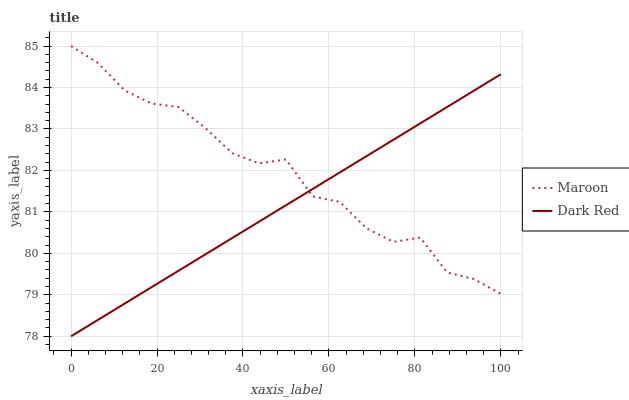Does Dark Red have the minimum area under the curve?
Answer yes or no. Yes. Does Maroon have the maximum area under the curve?
Answer yes or no. Yes. Does Maroon have the minimum area under the curve?
Answer yes or no. No. Is Dark Red the smoothest?
Answer yes or no. Yes. Is Maroon the roughest?
Answer yes or no. Yes. Is Maroon the smoothest?
Answer yes or no. No. Does Dark Red have the lowest value?
Answer yes or no. Yes. Does Maroon have the lowest value?
Answer yes or no. No. Does Maroon have the highest value?
Answer yes or no. Yes. Does Maroon intersect Dark Red?
Answer yes or no. Yes. Is Maroon less than Dark Red?
Answer yes or no. No. Is Maroon greater than Dark Red?
Answer yes or no. No. 